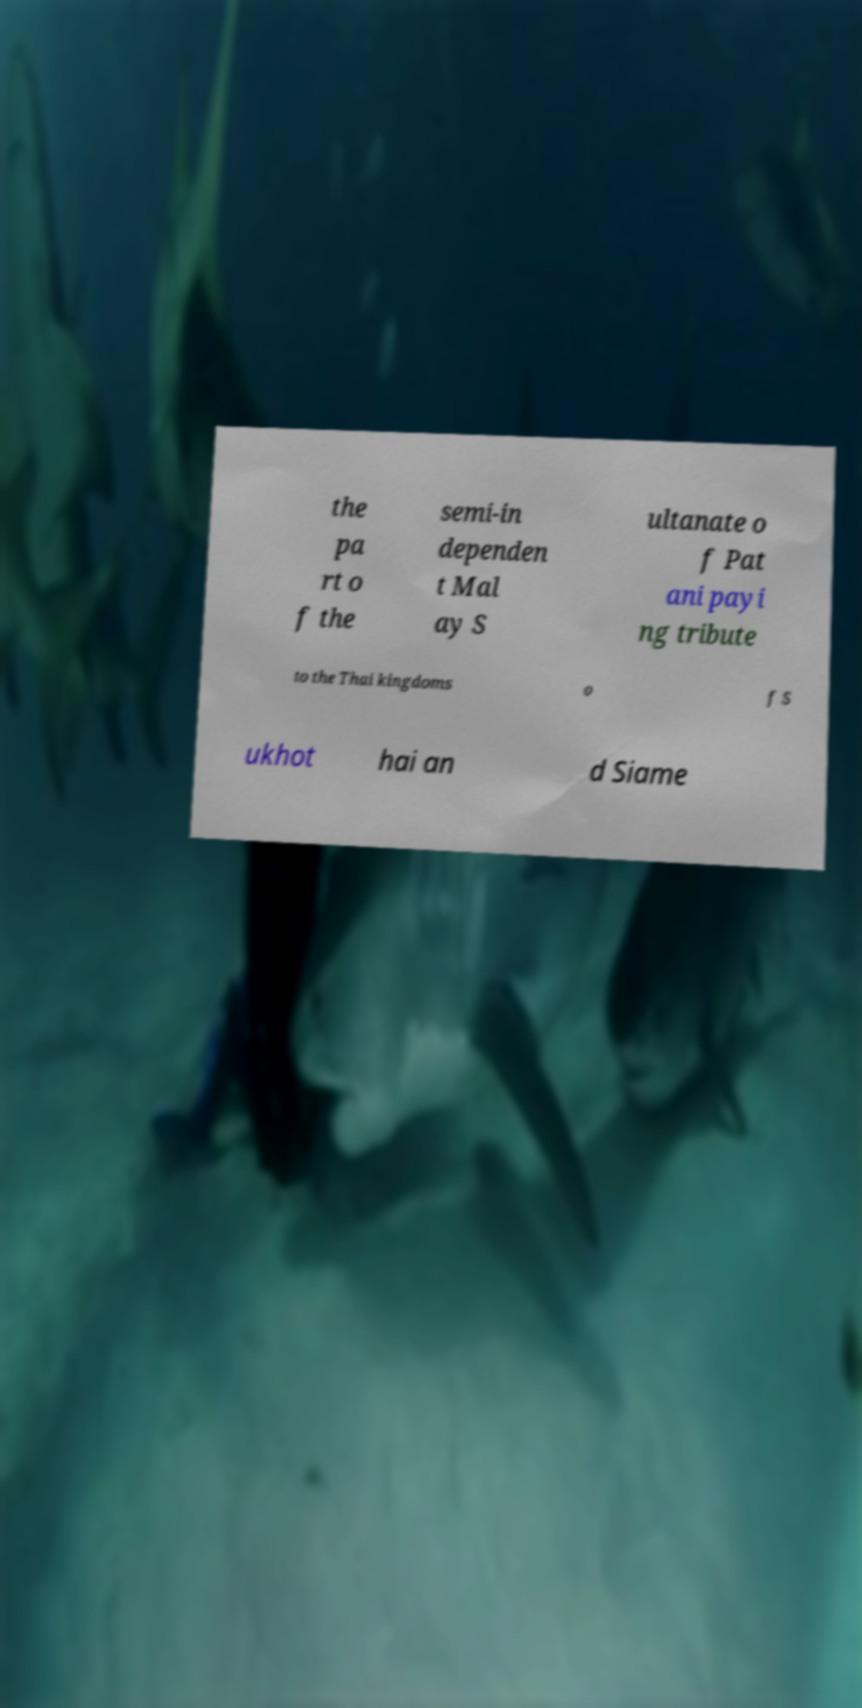Please identify and transcribe the text found in this image. the pa rt o f the semi-in dependen t Mal ay S ultanate o f Pat ani payi ng tribute to the Thai kingdoms o f S ukhot hai an d Siame 